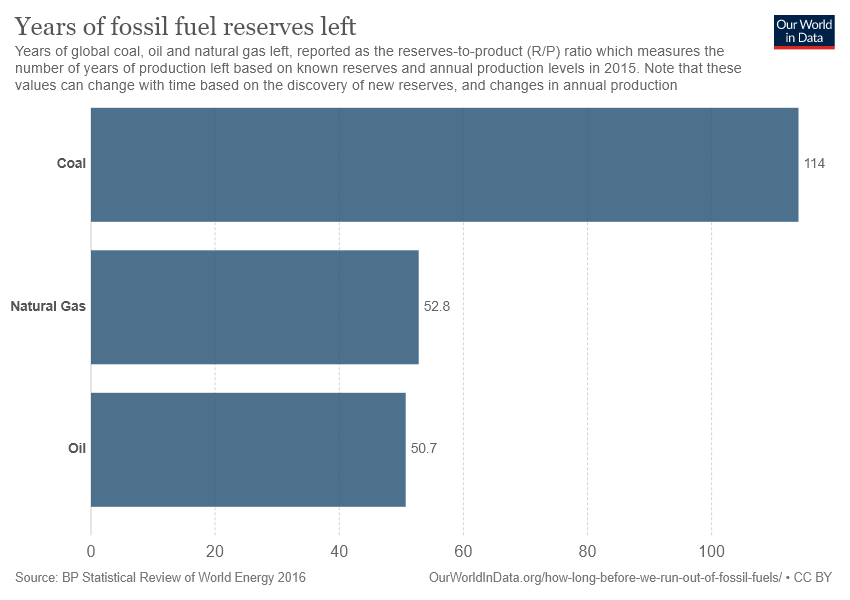List a handful of essential elements in this visual. The ratio of coal and natural gas is 0.0381111111... The document "What is the Difference Between Natural Gas and Oil?" explains the variations in natural gas and oil, including their properties, uses, and production methods. The document concludes that while both natural gas and oil are energy resources, they have distinct differences in terms of their properties, uses, and environmental impacts. 